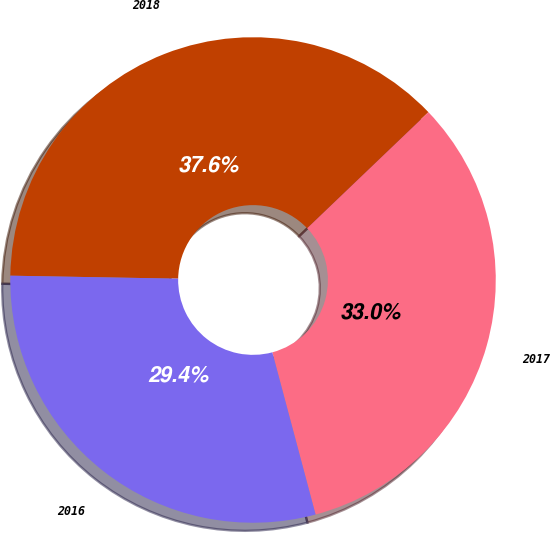<chart> <loc_0><loc_0><loc_500><loc_500><pie_chart><fcel>2018<fcel>2017<fcel>2016<nl><fcel>37.57%<fcel>33.0%<fcel>29.43%<nl></chart> 